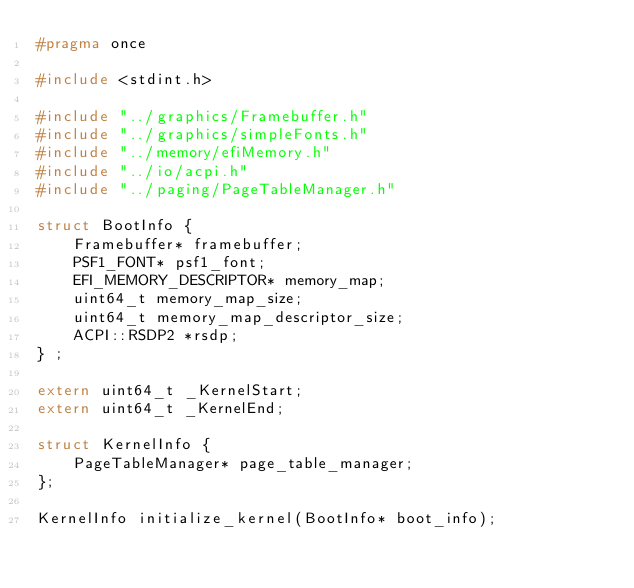Convert code to text. <code><loc_0><loc_0><loc_500><loc_500><_C_>#pragma once

#include <stdint.h>

#include "../graphics/Framebuffer.h"
#include "../graphics/simpleFonts.h"
#include "../memory/efiMemory.h"
#include "../io/acpi.h"
#include "../paging/PageTableManager.h"

struct BootInfo {
	Framebuffer* framebuffer;
	PSF1_FONT* psf1_font;
	EFI_MEMORY_DESCRIPTOR* memory_map;
	uint64_t memory_map_size;
	uint64_t memory_map_descriptor_size;
	ACPI::RSDP2 *rsdp;
} ;

extern uint64_t _KernelStart;
extern uint64_t _KernelEnd;

struct KernelInfo {
    PageTableManager* page_table_manager;
};

KernelInfo initialize_kernel(BootInfo* boot_info);</code> 